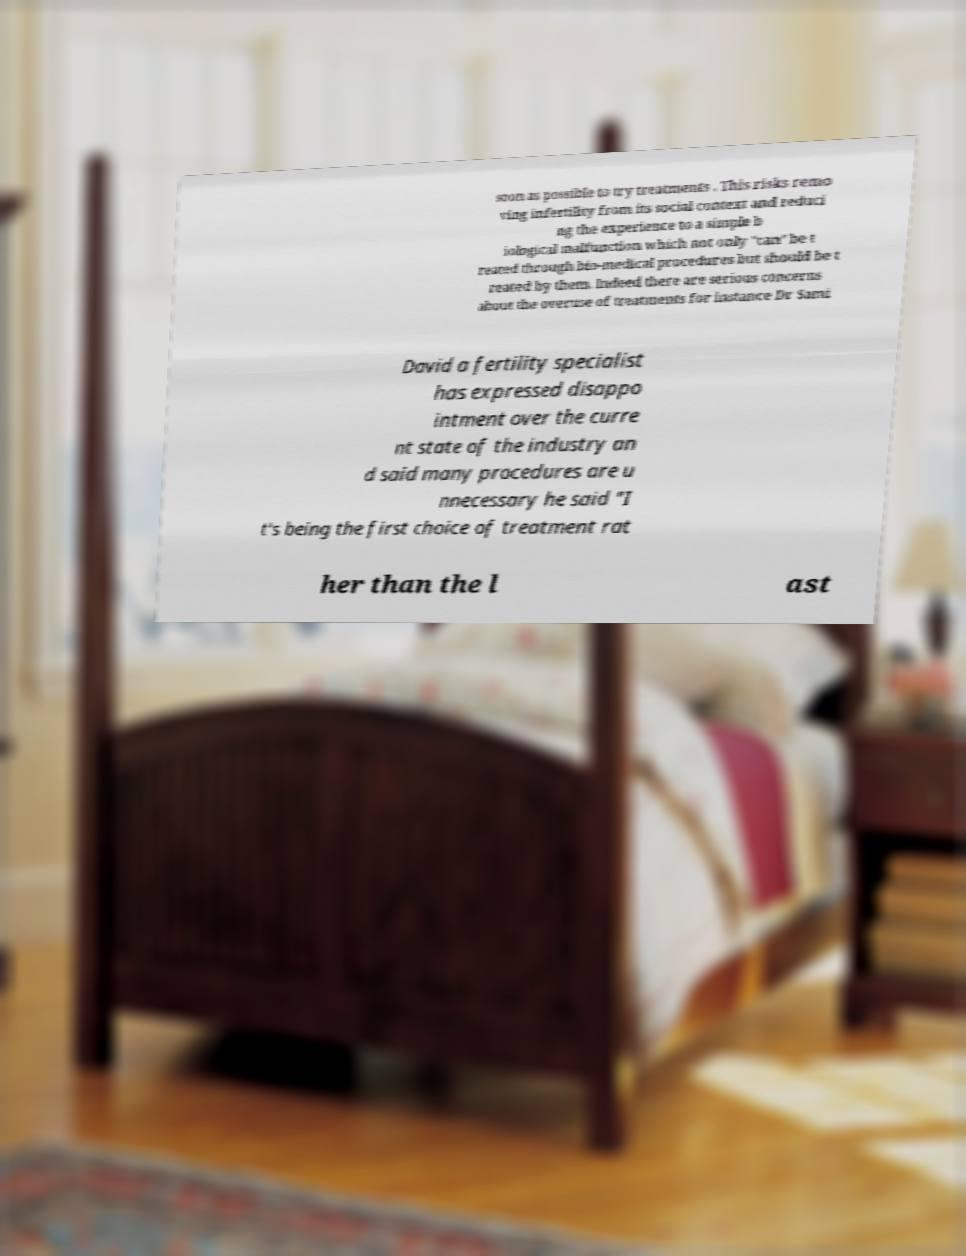There's text embedded in this image that I need extracted. Can you transcribe it verbatim? soon as possible to try treatments . This risks remo ving infertility from its social context and reduci ng the experience to a simple b iological malfunction which not only "can" be t reated through bio-medical procedures but should be t reated by them. Indeed there are serious concerns about the overuse of treatments for instance Dr Sami David a fertility specialist has expressed disappo intment over the curre nt state of the industry an d said many procedures are u nnecessary he said "I t's being the first choice of treatment rat her than the l ast 